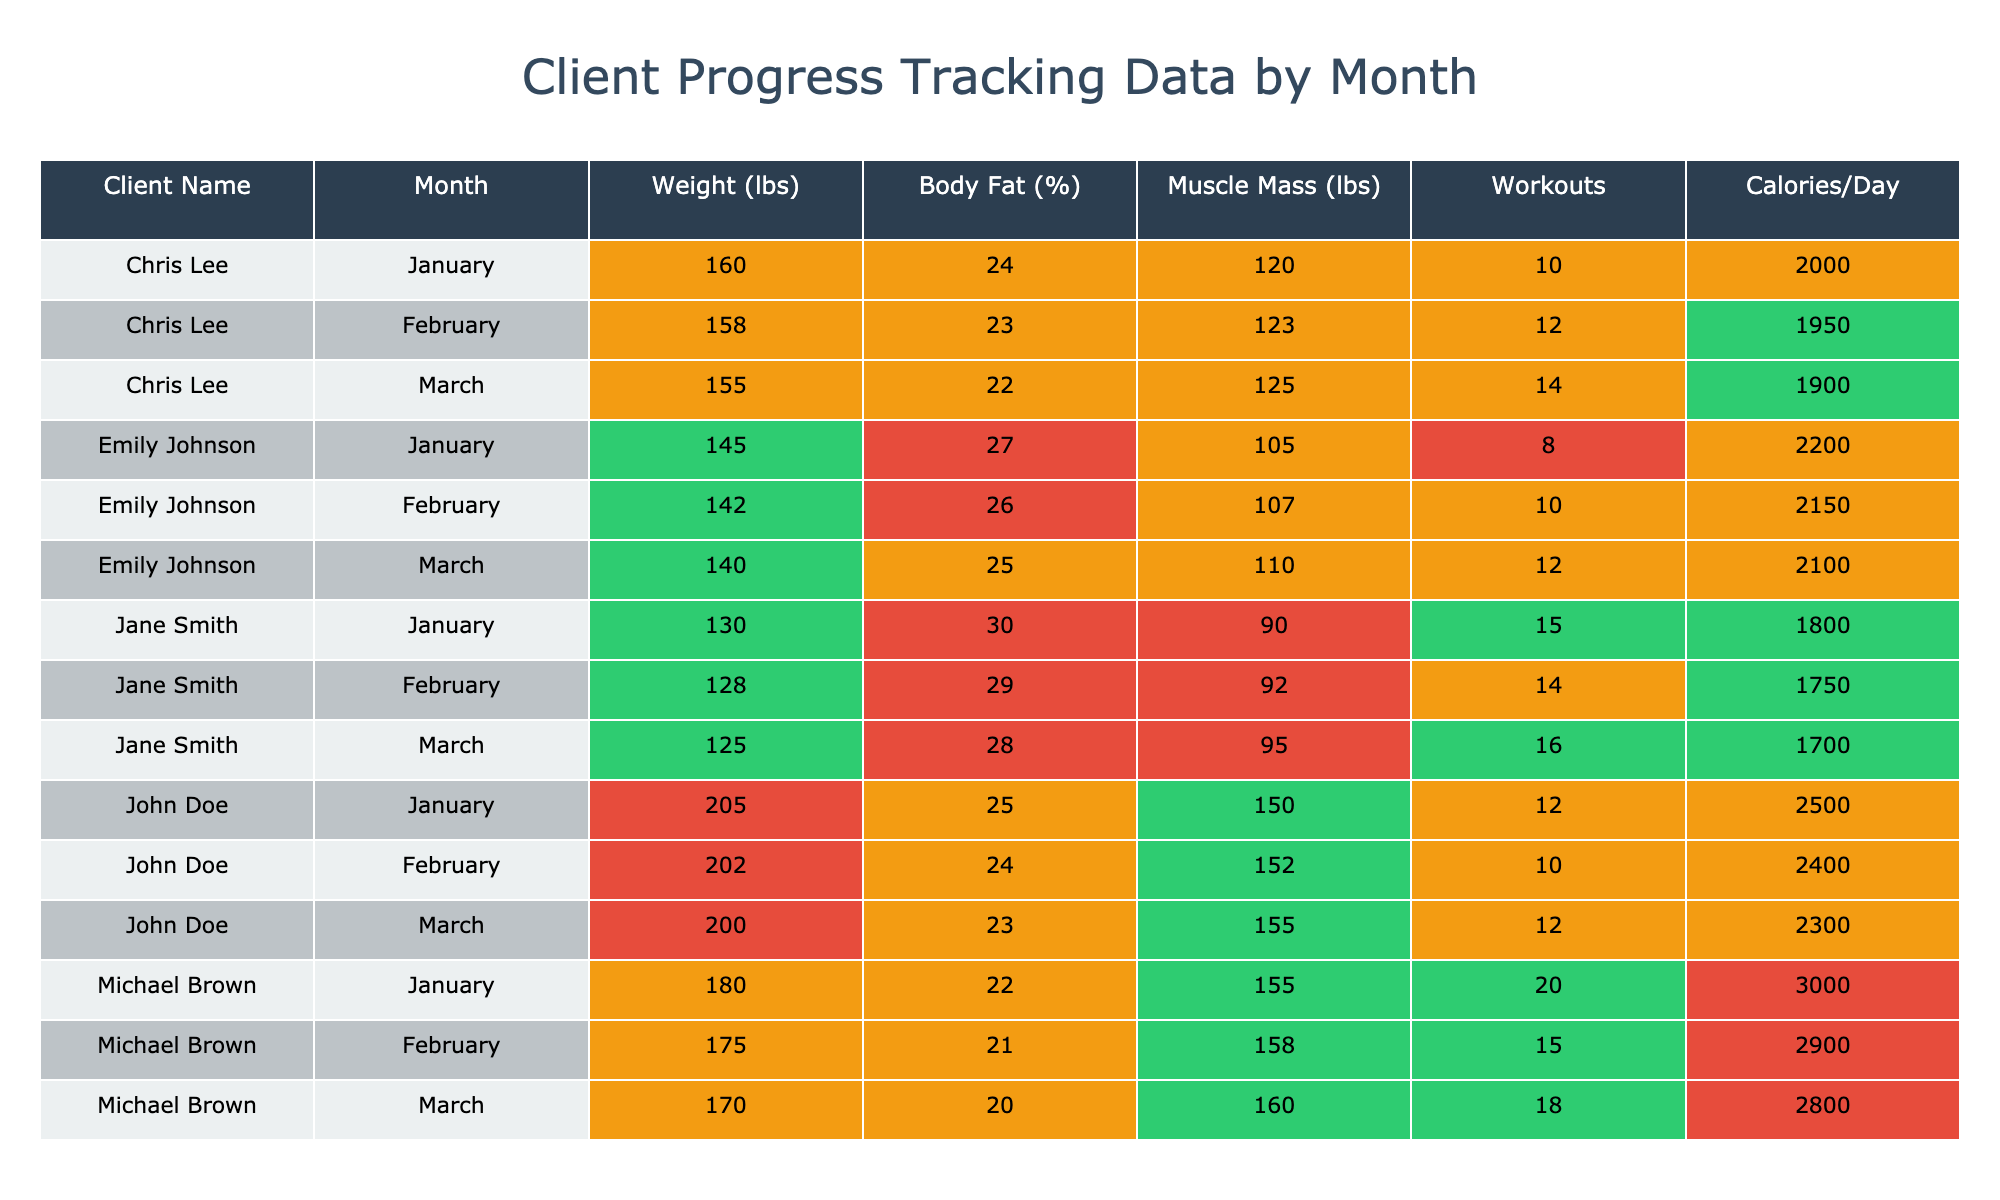What was John Doe's weight in February? Looking at the row for John Doe in February, the value under the "Weight (lbs)" column is 202.
Answer: 202 What is the average Body Fat Percentage for Jane Smith over the three months? The Body Fat Percentages for Jane Smith are 30, 29, and 28. First, add them up: 30 + 29 + 28 = 87. Then divide by the number of months (3): 87 / 3 = 29.
Answer: 29 Did Michael Brown complete more than 15 workouts in February? In the row for Michael Brown in February, the "Workouts Completed" column shows 15, which is not more than 15.
Answer: No What is the difference in muscle mass for Emily Johnson from January to March? In January, Emily's Muscle Mass is 105 lbs, and in March it is 110 lbs. To find the difference, subtract the January value from the March value: 110 - 105 = 5.
Answer: 5 Which client had the highest weight in January? By looking at the weights for January, John Doe had 205 lbs, which is greater than Michael Brown's 180 lbs or any other client listed.
Answer: John Doe What is the total number of workouts completed by Chris Lee in January and February combined? Chris Lee completed 10 workouts in January and 12 in February. Adding these together gives: 10 + 12 = 22 workouts.
Answer: 22 Is Emily Johnson's average daily calorie consumption lower than 2200? Emily Johnson's daily calorie consumption for January, February, and March is 2200, 2150, and 2100 respectively. The average is (2200 + 2150 + 2100) / 3 = 2150, which is lower than 2200.
Answer: Yes What was the highest body fat percentage recorded among all clients in March? In the March data, the body fat percentages are 23, 28, 25, 20, and 22. The highest value among these is 28 (Jane Smith).
Answer: 28 What was the change in weight for Michael Brown from January to March? Michael Brown's weight in January is 180 lbs and in March is 170 lbs. The change is calculated as 180 - 170 = 10 lbs loss.
Answer: 10 lbs loss 